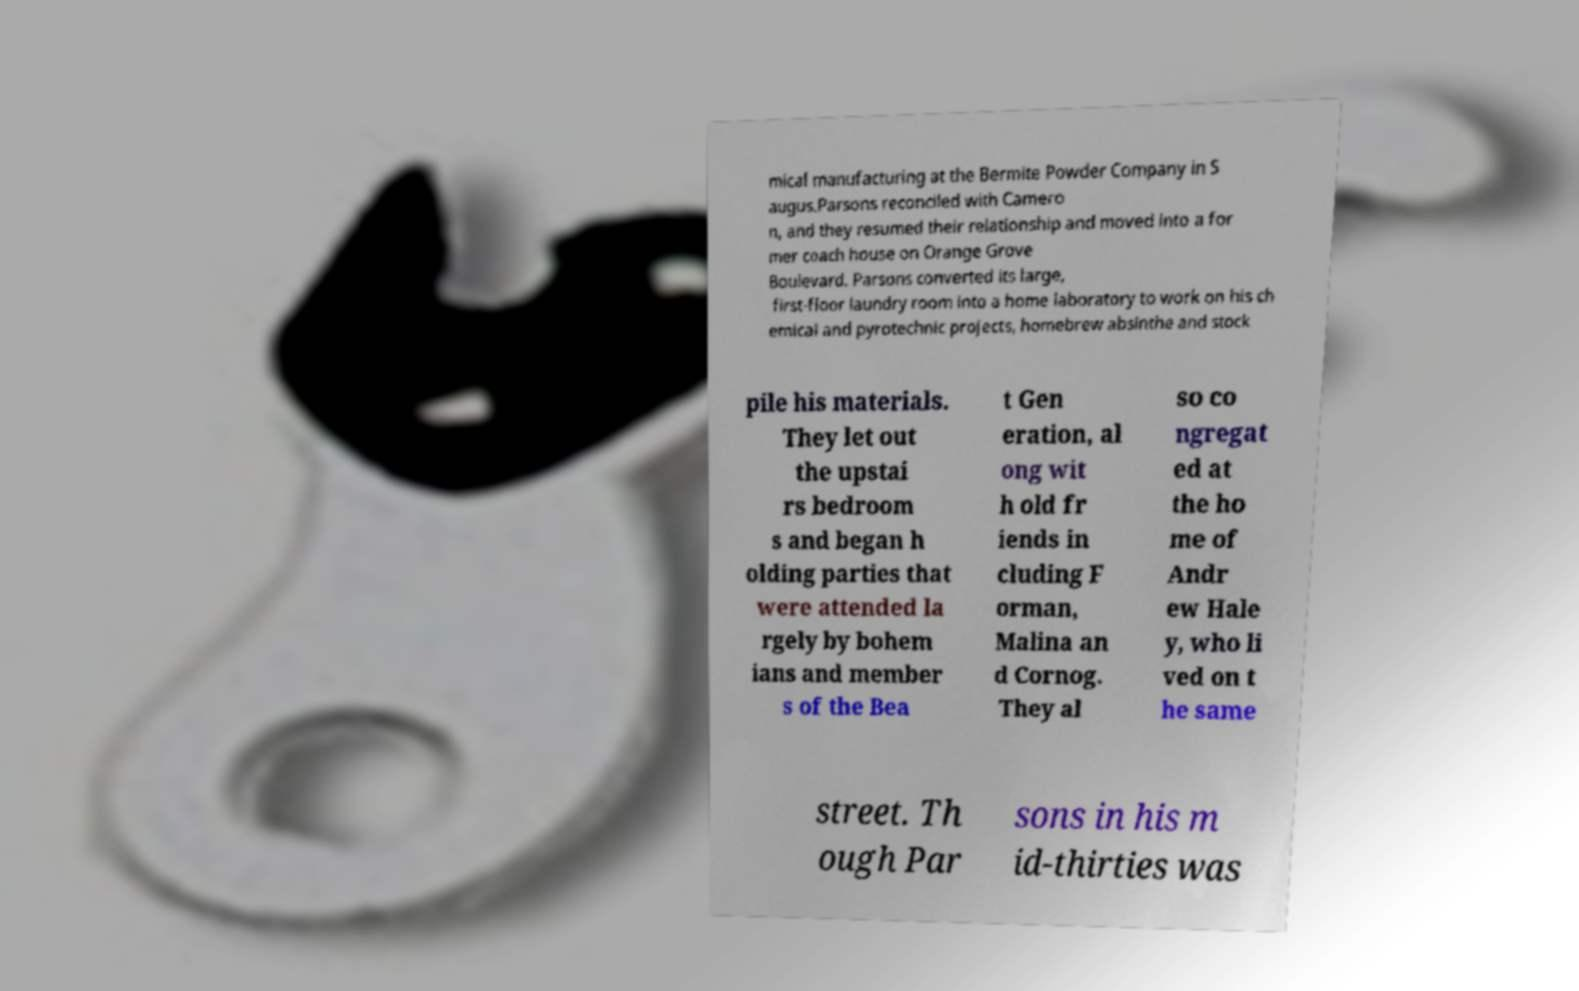For documentation purposes, I need the text within this image transcribed. Could you provide that? mical manufacturing at the Bermite Powder Company in S augus.Parsons reconciled with Camero n, and they resumed their relationship and moved into a for mer coach house on Orange Grove Boulevard. Parsons converted its large, first-floor laundry room into a home laboratory to work on his ch emical and pyrotechnic projects, homebrew absinthe and stock pile his materials. They let out the upstai rs bedroom s and began h olding parties that were attended la rgely by bohem ians and member s of the Bea t Gen eration, al ong wit h old fr iends in cluding F orman, Malina an d Cornog. They al so co ngregat ed at the ho me of Andr ew Hale y, who li ved on t he same street. Th ough Par sons in his m id-thirties was 